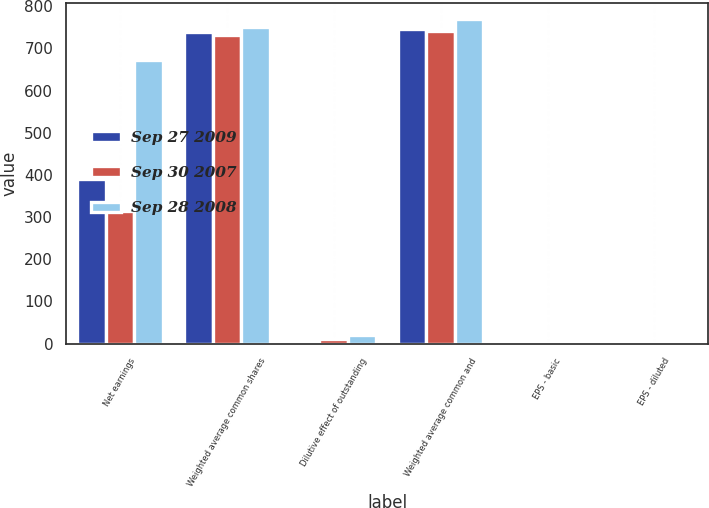<chart> <loc_0><loc_0><loc_500><loc_500><stacked_bar_chart><ecel><fcel>Net earnings<fcel>Weighted average common shares<fcel>Dilutive effect of outstanding<fcel>Weighted average common and<fcel>EPS - basic<fcel>EPS - diluted<nl><fcel>Sep 27 2009<fcel>390.8<fcel>738.7<fcel>7.2<fcel>745.9<fcel>0.53<fcel>0.52<nl><fcel>Sep 30 2007<fcel>315.5<fcel>731.5<fcel>10.2<fcel>741.7<fcel>0.43<fcel>0.43<nl><fcel>Sep 28 2008<fcel>672.6<fcel>749.8<fcel>20.3<fcel>770.1<fcel>0.9<fcel>0.87<nl></chart> 